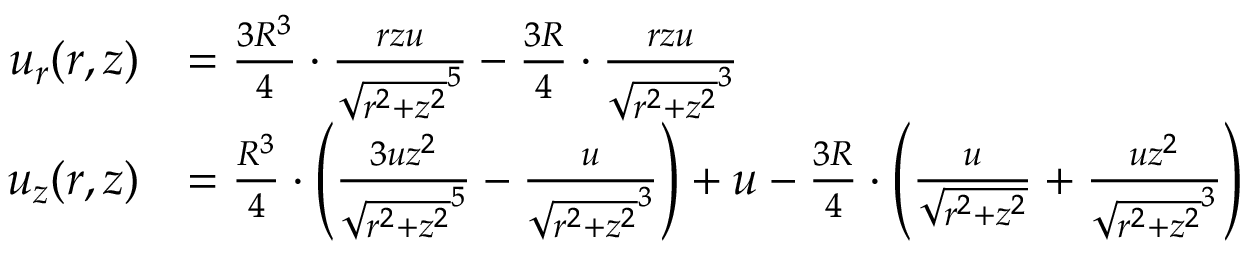<formula> <loc_0><loc_0><loc_500><loc_500>{ \begin{array} { r l } { u _ { r } ( r , z ) } & { = { \frac { 3 R ^ { 3 } } { 4 } } \cdot { \frac { r z u } { { \sqrt { r ^ { 2 } + z ^ { 2 } } } ^ { 5 } } } - { \frac { 3 R } { 4 } } \cdot { \frac { r z u } { { \sqrt { r ^ { 2 } + z ^ { 2 } } } ^ { 3 } } } } \\ { u _ { z } ( r , z ) } & { = { \frac { R ^ { 3 } } { 4 } } \cdot \left ( { \frac { 3 u z ^ { 2 } } { { \sqrt { r ^ { 2 } + z ^ { 2 } } } ^ { 5 } } } - { \frac { u } { { \sqrt { r ^ { 2 } + z ^ { 2 } } } ^ { 3 } } } \right ) + u - { \frac { 3 R } { 4 } } \cdot \left ( { \frac { u } { \sqrt { r ^ { 2 } + z ^ { 2 } } } } + { \frac { u z ^ { 2 } } { { \sqrt { r ^ { 2 } + z ^ { 2 } } } ^ { 3 } } } \right ) } \end{array} }</formula> 